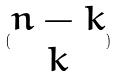<formula> <loc_0><loc_0><loc_500><loc_500>( \begin{matrix} n - k \\ k \end{matrix} )</formula> 